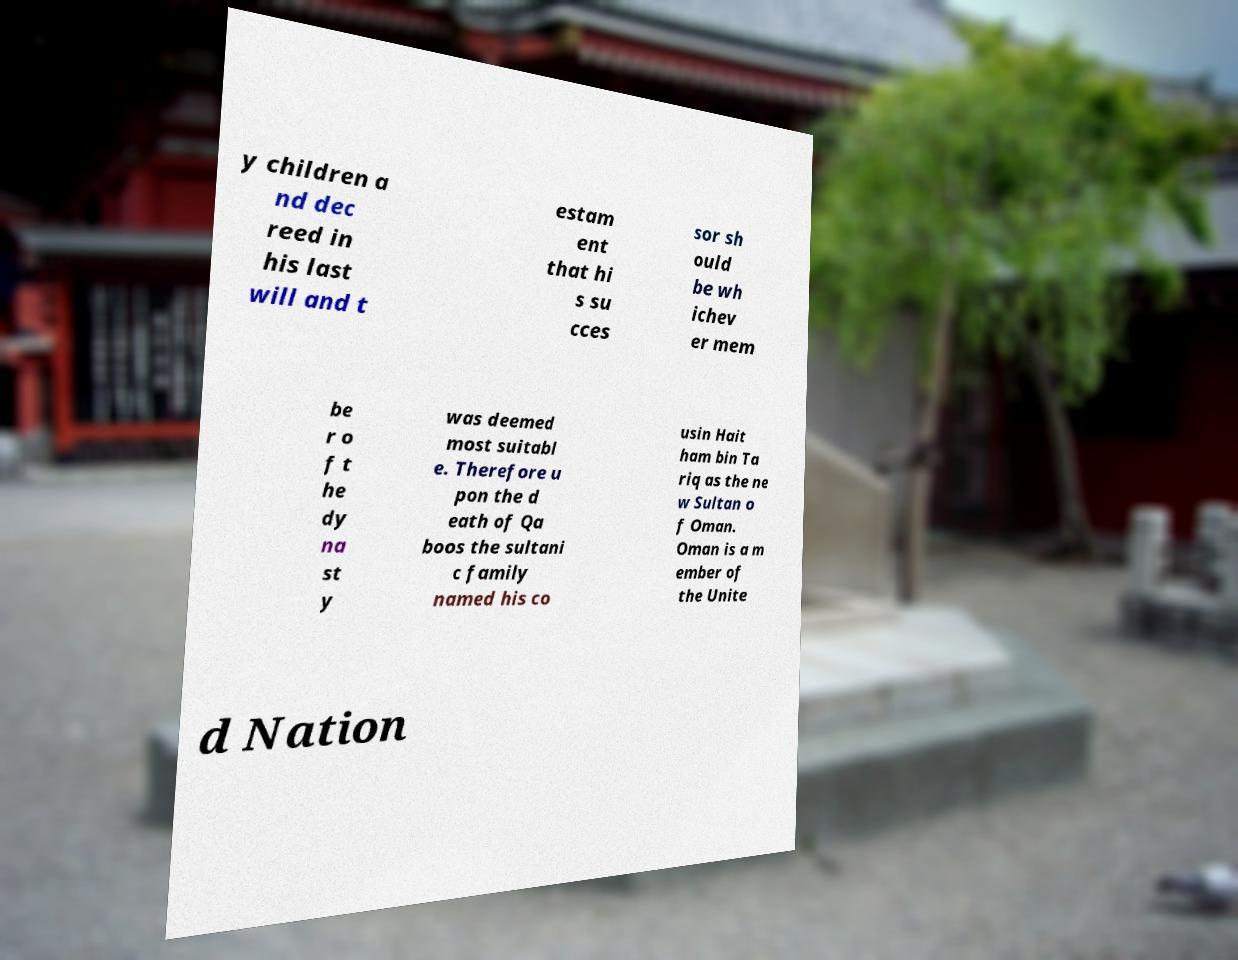Can you read and provide the text displayed in the image?This photo seems to have some interesting text. Can you extract and type it out for me? y children a nd dec reed in his last will and t estam ent that hi s su cces sor sh ould be wh ichev er mem be r o f t he dy na st y was deemed most suitabl e. Therefore u pon the d eath of Qa boos the sultani c family named his co usin Hait ham bin Ta riq as the ne w Sultan o f Oman. Oman is a m ember of the Unite d Nation 